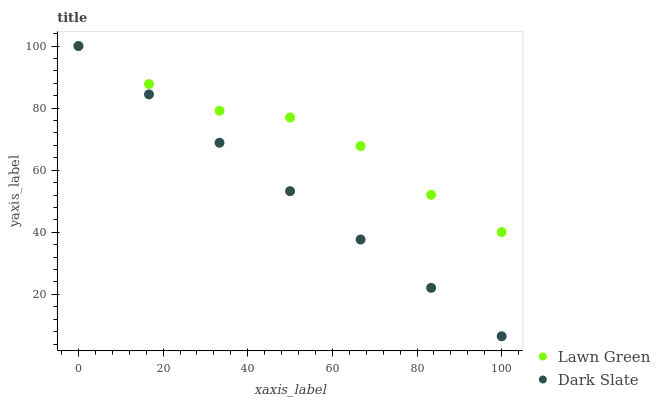Does Dark Slate have the minimum area under the curve?
Answer yes or no. Yes. Does Lawn Green have the maximum area under the curve?
Answer yes or no. Yes. Does Dark Slate have the maximum area under the curve?
Answer yes or no. No. Is Dark Slate the smoothest?
Answer yes or no. Yes. Is Lawn Green the roughest?
Answer yes or no. Yes. Is Dark Slate the roughest?
Answer yes or no. No. Does Dark Slate have the lowest value?
Answer yes or no. Yes. Does Dark Slate have the highest value?
Answer yes or no. Yes. Does Lawn Green intersect Dark Slate?
Answer yes or no. Yes. Is Lawn Green less than Dark Slate?
Answer yes or no. No. Is Lawn Green greater than Dark Slate?
Answer yes or no. No. 